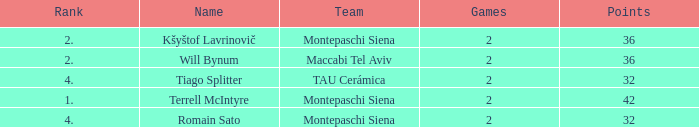What is the highest game that has 32 points and a team rank larger than 4 named montepaschi siena None. 